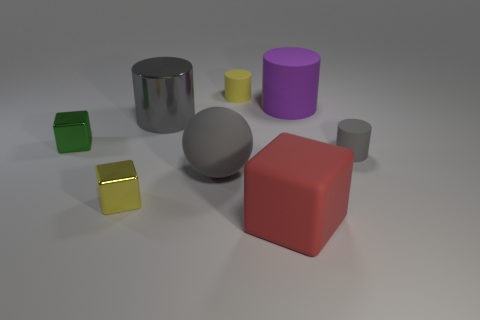Are there any patterns in how the objects are arranged? Yes, there seems to be a subtle pattern in the arrangement of the objects. They are spaced out across the surface in an orderly manner, with varying distances between them, and no two objects of the same shape are placed next to each other, suggesting intentional placement for visual diversity. 